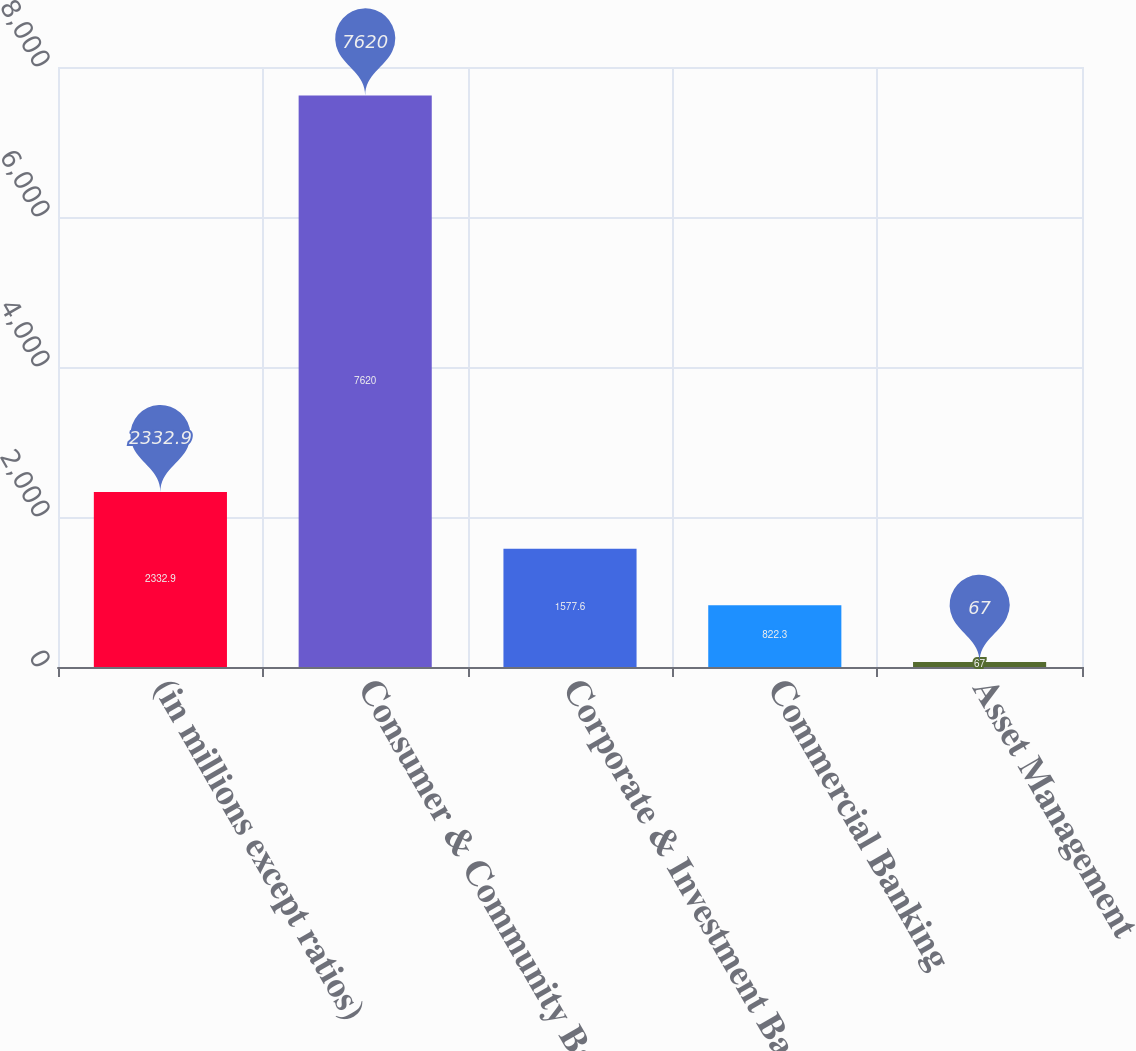<chart> <loc_0><loc_0><loc_500><loc_500><bar_chart><fcel>(in millions except ratios)<fcel>Consumer & Community Banking<fcel>Corporate & Investment Bank<fcel>Commercial Banking<fcel>Asset Management<nl><fcel>2332.9<fcel>7620<fcel>1577.6<fcel>822.3<fcel>67<nl></chart> 